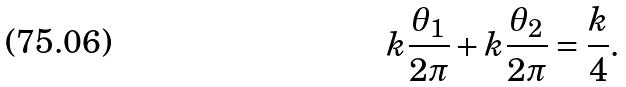Convert formula to latex. <formula><loc_0><loc_0><loc_500><loc_500>k \frac { \theta _ { 1 } } { 2 \pi } + k \frac { \theta _ { 2 } } { 2 \pi } = \frac { k } { 4 } .</formula> 